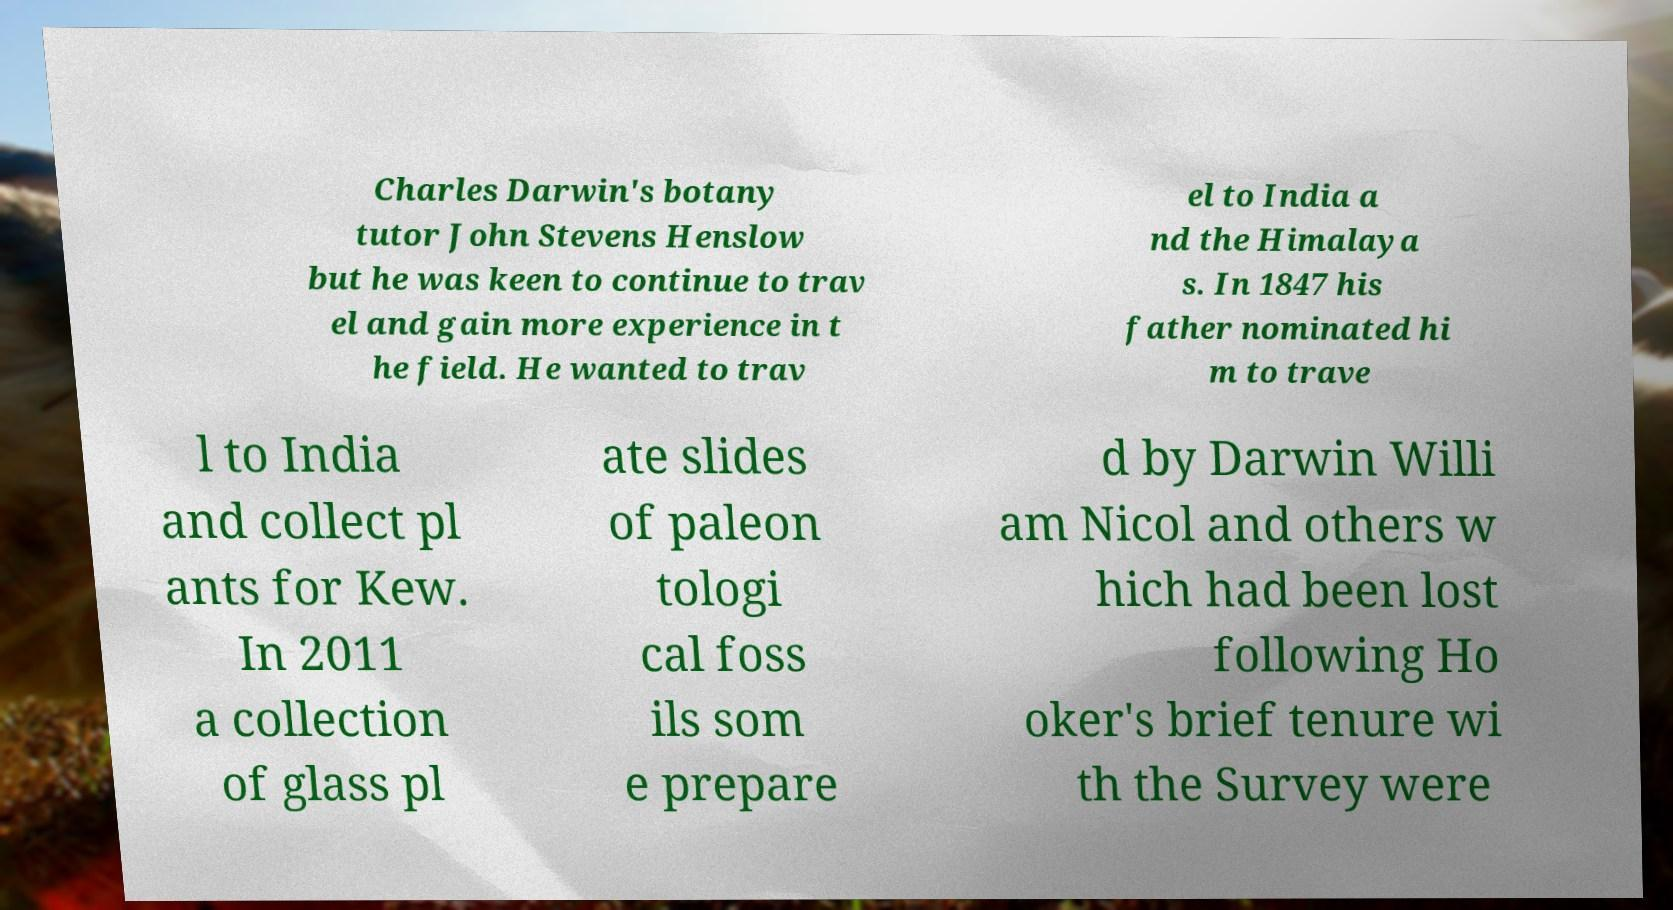Please read and relay the text visible in this image. What does it say? Charles Darwin's botany tutor John Stevens Henslow but he was keen to continue to trav el and gain more experience in t he field. He wanted to trav el to India a nd the Himalaya s. In 1847 his father nominated hi m to trave l to India and collect pl ants for Kew. In 2011 a collection of glass pl ate slides of paleon tologi cal foss ils som e prepare d by Darwin Willi am Nicol and others w hich had been lost following Ho oker's brief tenure wi th the Survey were 